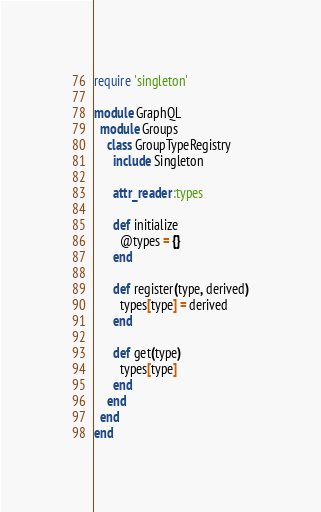<code> <loc_0><loc_0><loc_500><loc_500><_Ruby_>require 'singleton'

module GraphQL
  module Groups
    class GroupTypeRegistry
      include Singleton

      attr_reader :types

      def initialize
        @types = {}
      end

      def register(type, derived)
        types[type] = derived
      end

      def get(type)
        types[type]
      end
    end
  end
end
</code> 